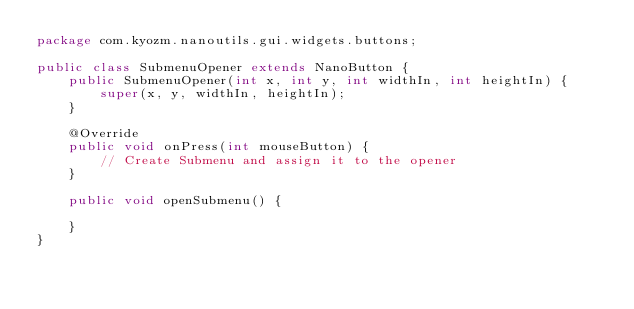Convert code to text. <code><loc_0><loc_0><loc_500><loc_500><_Java_>package com.kyozm.nanoutils.gui.widgets.buttons;

public class SubmenuOpener extends NanoButton {
    public SubmenuOpener(int x, int y, int widthIn, int heightIn) {
        super(x, y, widthIn, heightIn);
    }

    @Override
    public void onPress(int mouseButton) {
        // Create Submenu and assign it to the opener
    }

    public void openSubmenu() {

    }
}
</code> 